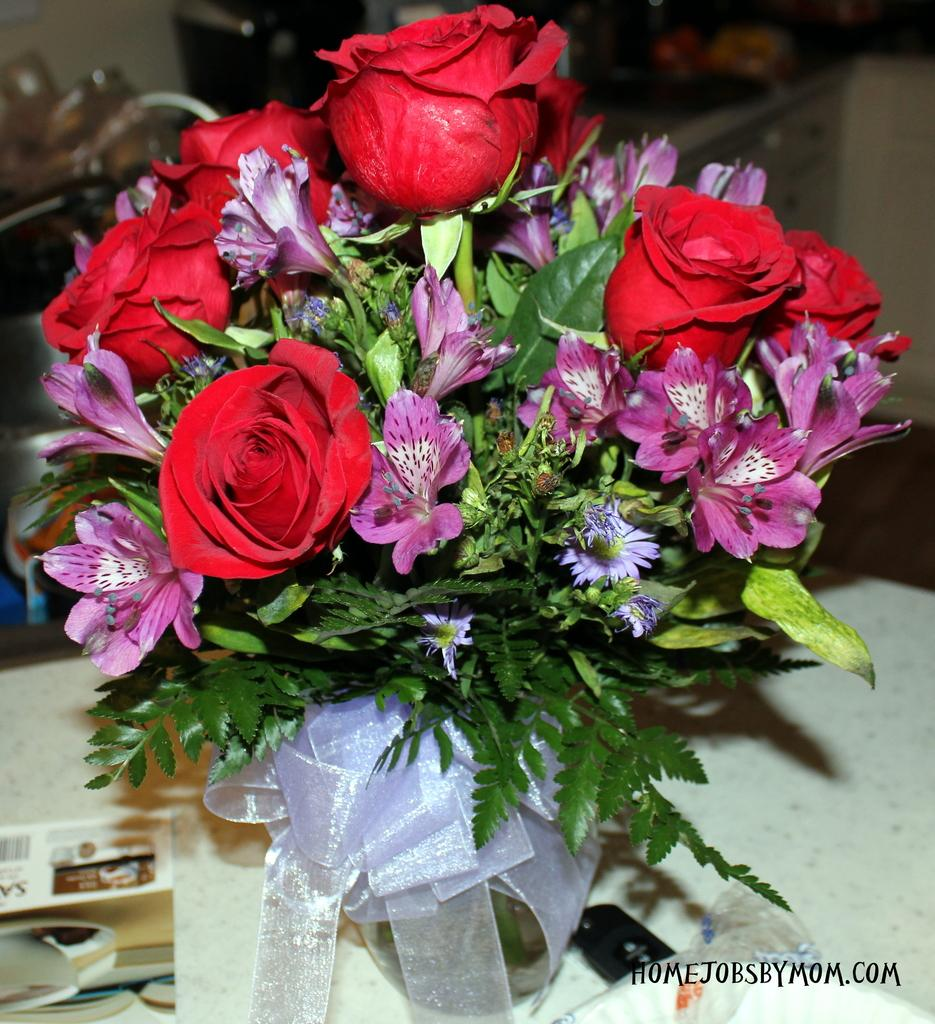What is the main subject of the image? There is a bouquet of flowers in the image. What type of flowers are included in the bouquet? The bouquet includes roses. Are there any other types of flowers in the bouquet besides roses? Yes, there are other flowers in the bouquet. How is the bouquet decorated or held together? There is a ribbon at the bottom of the bouquet. Can you describe the appearance of the ribbon? The ribbon is transparent and white in color. How many sheep are present in the image? There are no sheep present in the image; it features a bouquet of flowers with a ribbon. What type of cheese is visible in the image? There is no cheese present in the image. 